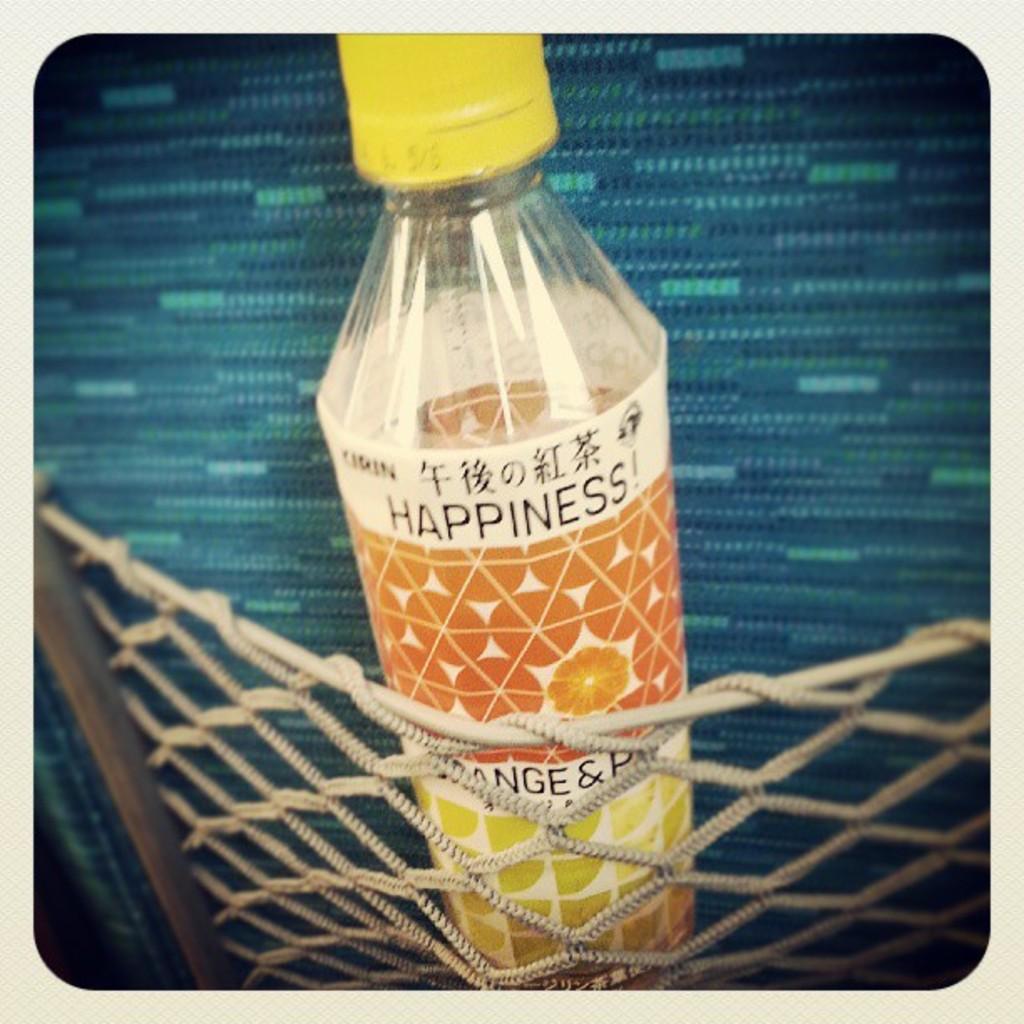What are 3 letters and one symbol you can see in between the net?
Offer a very short reply. Nge &. 